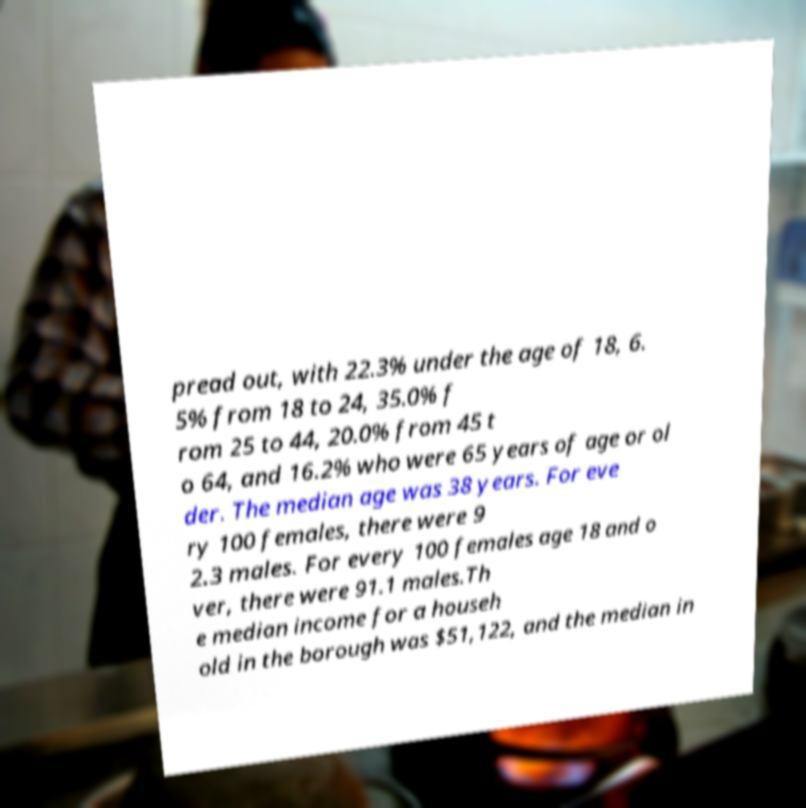Can you read and provide the text displayed in the image?This photo seems to have some interesting text. Can you extract and type it out for me? pread out, with 22.3% under the age of 18, 6. 5% from 18 to 24, 35.0% f rom 25 to 44, 20.0% from 45 t o 64, and 16.2% who were 65 years of age or ol der. The median age was 38 years. For eve ry 100 females, there were 9 2.3 males. For every 100 females age 18 and o ver, there were 91.1 males.Th e median income for a househ old in the borough was $51,122, and the median in 